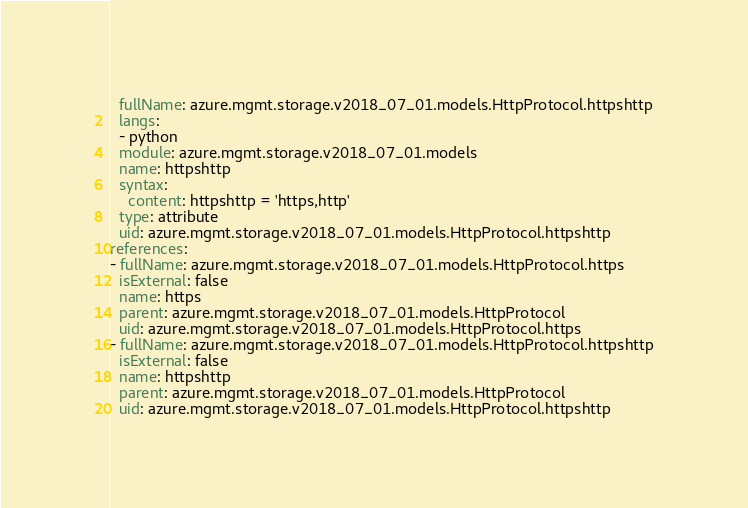Convert code to text. <code><loc_0><loc_0><loc_500><loc_500><_YAML_>  fullName: azure.mgmt.storage.v2018_07_01.models.HttpProtocol.httpshttp
  langs:
  - python
  module: azure.mgmt.storage.v2018_07_01.models
  name: httpshttp
  syntax:
    content: httpshttp = 'https,http'
  type: attribute
  uid: azure.mgmt.storage.v2018_07_01.models.HttpProtocol.httpshttp
references:
- fullName: azure.mgmt.storage.v2018_07_01.models.HttpProtocol.https
  isExternal: false
  name: https
  parent: azure.mgmt.storage.v2018_07_01.models.HttpProtocol
  uid: azure.mgmt.storage.v2018_07_01.models.HttpProtocol.https
- fullName: azure.mgmt.storage.v2018_07_01.models.HttpProtocol.httpshttp
  isExternal: false
  name: httpshttp
  parent: azure.mgmt.storage.v2018_07_01.models.HttpProtocol
  uid: azure.mgmt.storage.v2018_07_01.models.HttpProtocol.httpshttp
</code> 